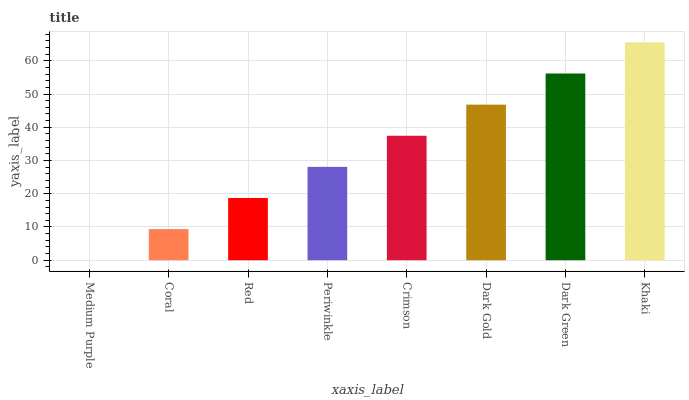Is Medium Purple the minimum?
Answer yes or no. Yes. Is Khaki the maximum?
Answer yes or no. Yes. Is Coral the minimum?
Answer yes or no. No. Is Coral the maximum?
Answer yes or no. No. Is Coral greater than Medium Purple?
Answer yes or no. Yes. Is Medium Purple less than Coral?
Answer yes or no. Yes. Is Medium Purple greater than Coral?
Answer yes or no. No. Is Coral less than Medium Purple?
Answer yes or no. No. Is Crimson the high median?
Answer yes or no. Yes. Is Periwinkle the low median?
Answer yes or no. Yes. Is Dark Green the high median?
Answer yes or no. No. Is Medium Purple the low median?
Answer yes or no. No. 